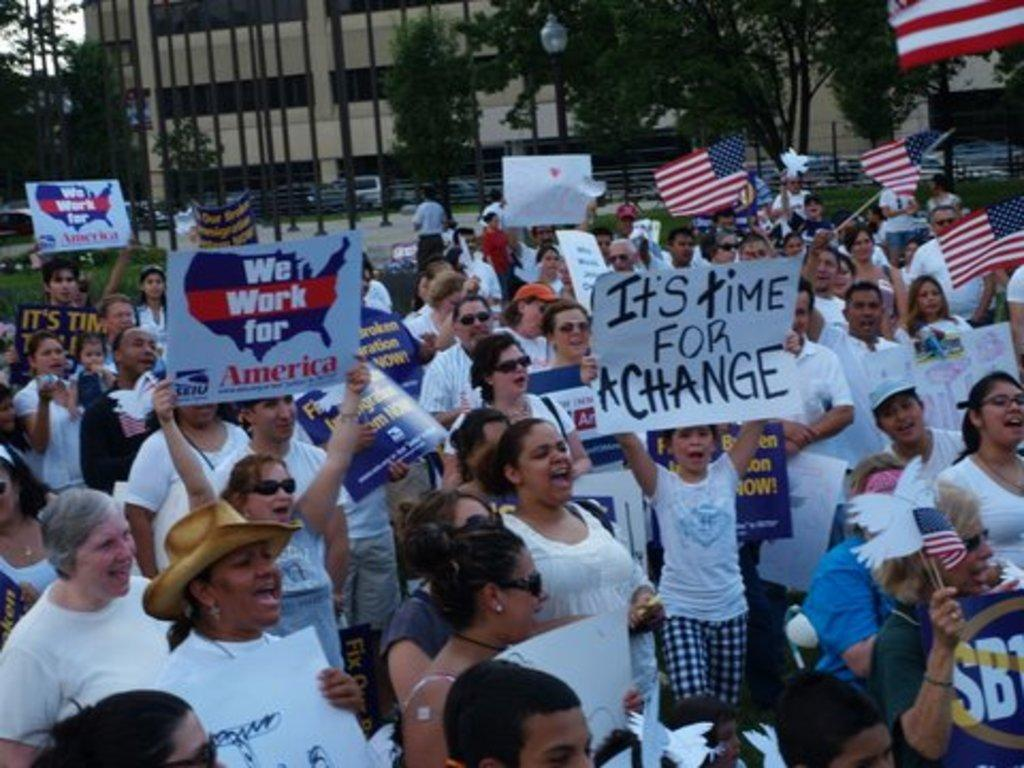What is happening in the image? There are persons standing in the image. What are some of the persons holding? Some of the persons are holding boards and flags. What can be seen in the background of the image? There are trees and buildings in the background of the image. How many snakes are slithering on the leaf in the image? There are no snakes or leaves present in the image. 